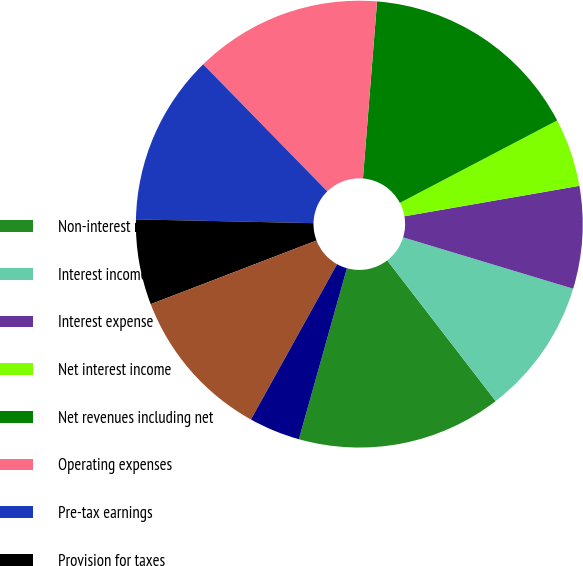Convert chart. <chart><loc_0><loc_0><loc_500><loc_500><pie_chart><fcel>Non-interest revenues<fcel>Interest income<fcel>Interest expense<fcel>Net interest income<fcel>Net revenues including net<fcel>Operating expenses<fcel>Pre-tax earnings<fcel>Provision for taxes<fcel>Net earnings<fcel>Preferred stock dividends<nl><fcel>14.81%<fcel>9.88%<fcel>7.41%<fcel>4.94%<fcel>16.05%<fcel>13.58%<fcel>12.35%<fcel>6.17%<fcel>11.11%<fcel>3.7%<nl></chart> 